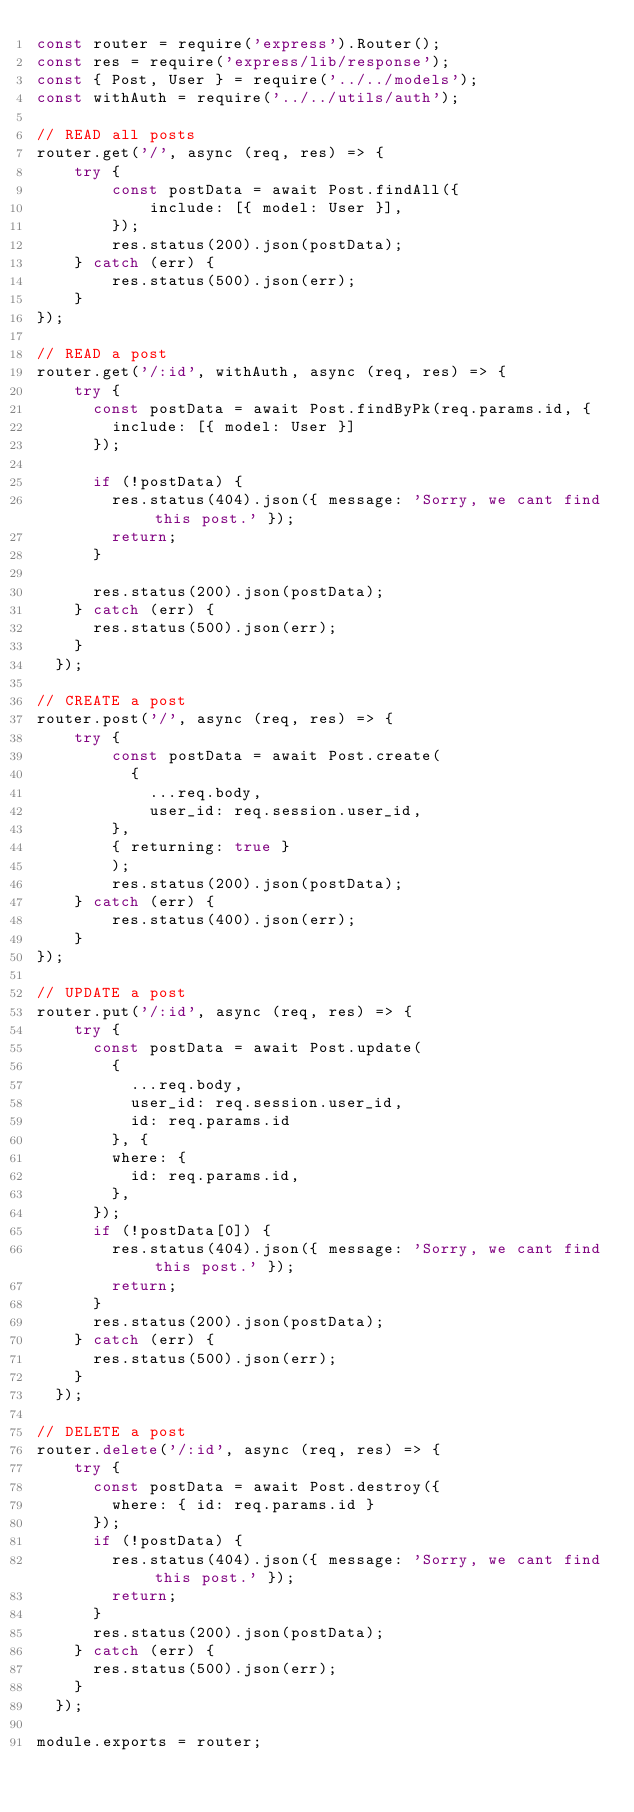<code> <loc_0><loc_0><loc_500><loc_500><_JavaScript_>const router = require('express').Router();
const res = require('express/lib/response');
const { Post, User } = require('../../models');
const withAuth = require('../../utils/auth');

// READ all posts
router.get('/', async (req, res) => {
    try {
        const postData = await Post.findAll({
            include: [{ model: User }],
        });
        res.status(200).json(postData);
    } catch (err) {
        res.status(500).json(err);
    }
});

// READ a post
router.get('/:id', withAuth, async (req, res) => {
    try {
      const postData = await Post.findByPk(req.params.id, {
        include: [{ model: User }]
      });
  
      if (!postData) {
        res.status(404).json({ message: 'Sorry, we cant find this post.' });
        return;
      }
  
      res.status(200).json(postData);
    } catch (err) {
      res.status(500).json(err);
    }
  });

// CREATE a post
router.post('/', async (req, res) => {
    try {
        const postData = await Post.create(
          {
            ...req.body,
            user_id: req.session.user_id,
        },
        { returning: true }
        );
        res.status(200).json(postData);
    } catch (err) {
        res.status(400).json(err);
    }
});

// UPDATE a post
router.put('/:id', async (req, res) => {
    try {
      const postData = await Post.update(
        {
          ...req.body,
          user_id: req.session.user_id,
          id: req.params.id
        }, {
        where: {
          id: req.params.id,
        },
      });
      if (!postData[0]) {
        res.status(404).json({ message: 'Sorry, we cant find this post.' });
        return;
      }
      res.status(200).json(postData);
    } catch (err) {
      res.status(500).json(err);
    }
  });

// DELETE a post
router.delete('/:id', async (req, res) => {
    try {
      const postData = await Post.destroy({
        where: { id: req.params.id }
      });
      if (!postData) {
        res.status(404).json({ message: 'Sorry, we cant find this post.' });
        return;
      }
      res.status(200).json(postData);
    } catch (err) {
      res.status(500).json(err);
    }
  });

module.exports = router;</code> 